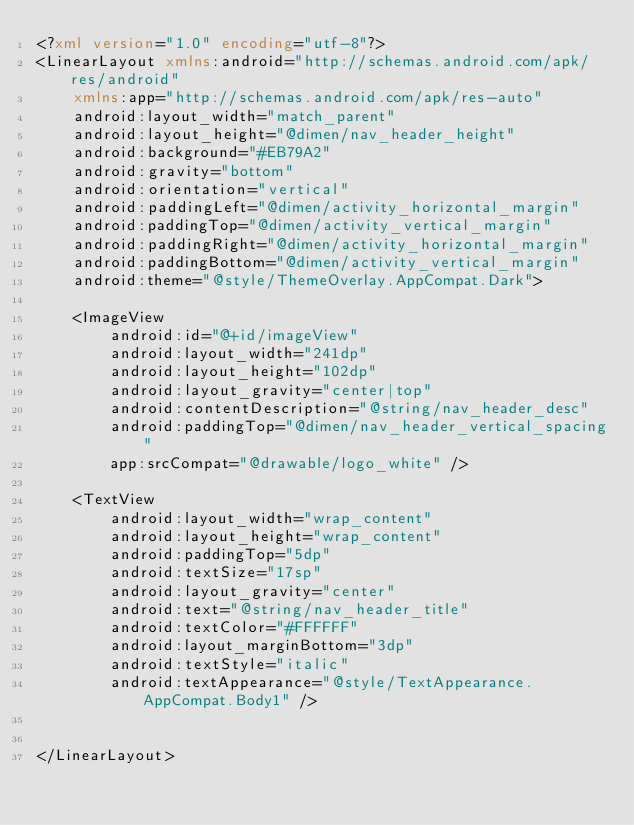<code> <loc_0><loc_0><loc_500><loc_500><_XML_><?xml version="1.0" encoding="utf-8"?>
<LinearLayout xmlns:android="http://schemas.android.com/apk/res/android"
    xmlns:app="http://schemas.android.com/apk/res-auto"
    android:layout_width="match_parent"
    android:layout_height="@dimen/nav_header_height"
    android:background="#EB79A2"
    android:gravity="bottom"
    android:orientation="vertical"
    android:paddingLeft="@dimen/activity_horizontal_margin"
    android:paddingTop="@dimen/activity_vertical_margin"
    android:paddingRight="@dimen/activity_horizontal_margin"
    android:paddingBottom="@dimen/activity_vertical_margin"
    android:theme="@style/ThemeOverlay.AppCompat.Dark">

    <ImageView
        android:id="@+id/imageView"
        android:layout_width="241dp"
        android:layout_height="102dp"
        android:layout_gravity="center|top"
        android:contentDescription="@string/nav_header_desc"
        android:paddingTop="@dimen/nav_header_vertical_spacing"
        app:srcCompat="@drawable/logo_white" />

    <TextView
        android:layout_width="wrap_content"
        android:layout_height="wrap_content"
        android:paddingTop="5dp"
        android:textSize="17sp"
        android:layout_gravity="center"
        android:text="@string/nav_header_title"
        android:textColor="#FFFFFF"
        android:layout_marginBottom="3dp"
        android:textStyle="italic"
        android:textAppearance="@style/TextAppearance.AppCompat.Body1" />


</LinearLayout></code> 